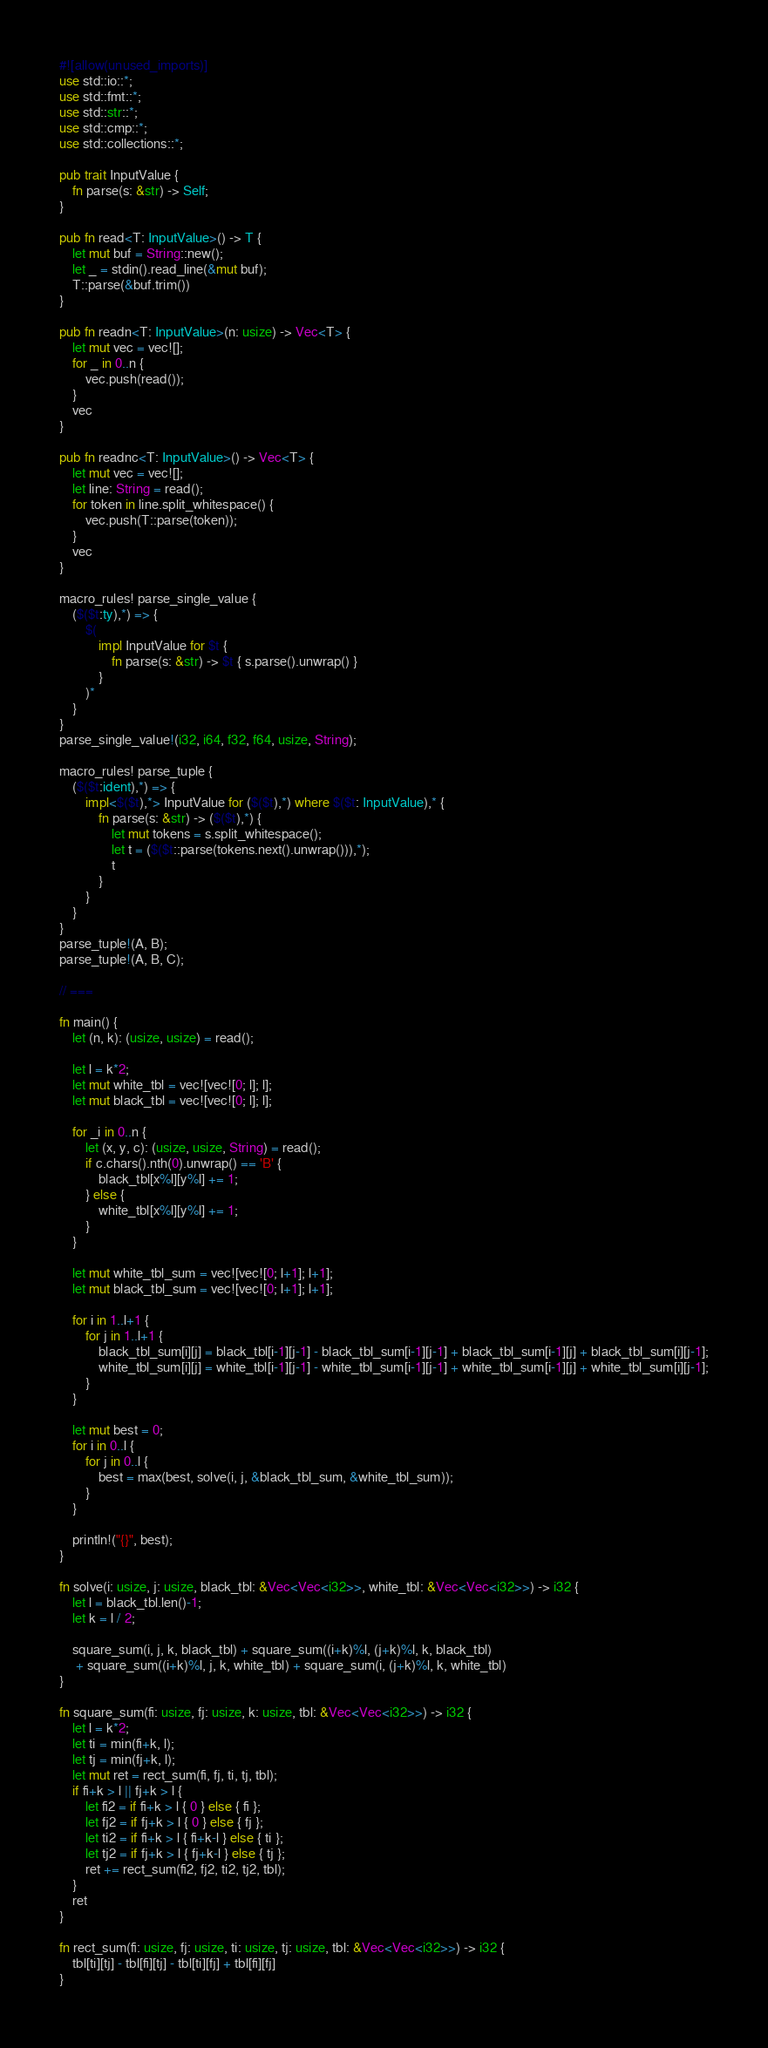<code> <loc_0><loc_0><loc_500><loc_500><_Rust_>#![allow(unused_imports)]
use std::io::*;
use std::fmt::*;
use std::str::*;
use std::cmp::*;
use std::collections::*;

pub trait InputValue {
    fn parse(s: &str) -> Self;
}

pub fn read<T: InputValue>() -> T {
    let mut buf = String::new();
    let _ = stdin().read_line(&mut buf);
    T::parse(&buf.trim())
}

pub fn readn<T: InputValue>(n: usize) -> Vec<T> {
    let mut vec = vec![];
    for _ in 0..n {
        vec.push(read());
    }
    vec
}

pub fn readnc<T: InputValue>() -> Vec<T> {
    let mut vec = vec![];
    let line: String = read();
    for token in line.split_whitespace() {
        vec.push(T::parse(token));
    }
    vec
}

macro_rules! parse_single_value {
    ($($t:ty),*) => {
        $(
            impl InputValue for $t {
                fn parse(s: &str) -> $t { s.parse().unwrap() }
            }
        )*
	}
}
parse_single_value!(i32, i64, f32, f64, usize, String);

macro_rules! parse_tuple {
	($($t:ident),*) => {
		impl<$($t),*> InputValue for ($($t),*) where $($t: InputValue),* {
			fn parse(s: &str) -> ($($t),*) {
				let mut tokens = s.split_whitespace();
				let t = ($($t::parse(tokens.next().unwrap())),*);
				t
			}
		}
	}
}
parse_tuple!(A, B);
parse_tuple!(A, B, C);

// ===

fn main() {
    let (n, k): (usize, usize) = read();

    let l = k*2;
    let mut white_tbl = vec![vec![0; l]; l];
    let mut black_tbl = vec![vec![0; l]; l];

    for _i in 0..n {
        let (x, y, c): (usize, usize, String) = read();
        if c.chars().nth(0).unwrap() == 'B' {
            black_tbl[x%l][y%l] += 1;
        } else {
            white_tbl[x%l][y%l] += 1;
        }
    }

    let mut white_tbl_sum = vec![vec![0; l+1]; l+1];
    let mut black_tbl_sum = vec![vec![0; l+1]; l+1];

    for i in 1..l+1 {
        for j in 1..l+1 {
            black_tbl_sum[i][j] = black_tbl[i-1][j-1] - black_tbl_sum[i-1][j-1] + black_tbl_sum[i-1][j] + black_tbl_sum[i][j-1];
            white_tbl_sum[i][j] = white_tbl[i-1][j-1] - white_tbl_sum[i-1][j-1] + white_tbl_sum[i-1][j] + white_tbl_sum[i][j-1];
        }
    }

    let mut best = 0;
    for i in 0..l {
        for j in 0..l {
            best = max(best, solve(i, j, &black_tbl_sum, &white_tbl_sum));
        }
    }
    
    println!("{}", best);
}

fn solve(i: usize, j: usize, black_tbl: &Vec<Vec<i32>>, white_tbl: &Vec<Vec<i32>>) -> i32 {
    let l = black_tbl.len()-1;
    let k = l / 2;

    square_sum(i, j, k, black_tbl) + square_sum((i+k)%l, (j+k)%l, k, black_tbl)
     + square_sum((i+k)%l, j, k, white_tbl) + square_sum(i, (j+k)%l, k, white_tbl)
}

fn square_sum(fi: usize, fj: usize, k: usize, tbl: &Vec<Vec<i32>>) -> i32 {
    let l = k*2;
    let ti = min(fi+k, l);
    let tj = min(fj+k, l);
    let mut ret = rect_sum(fi, fj, ti, tj, tbl);
    if fi+k > l || fj+k > l {
        let fi2 = if fi+k > l { 0 } else { fi };
        let fj2 = if fj+k > l { 0 } else { fj };
        let ti2 = if fi+k > l { fi+k-l } else { ti };
        let tj2 = if fj+k > l { fj+k-l } else { tj };
        ret += rect_sum(fi2, fj2, ti2, tj2, tbl);
    }
    ret
}

fn rect_sum(fi: usize, fj: usize, ti: usize, tj: usize, tbl: &Vec<Vec<i32>>) -> i32 {
    tbl[ti][tj] - tbl[fi][tj] - tbl[ti][fj] + tbl[fi][fj]
}
</code> 